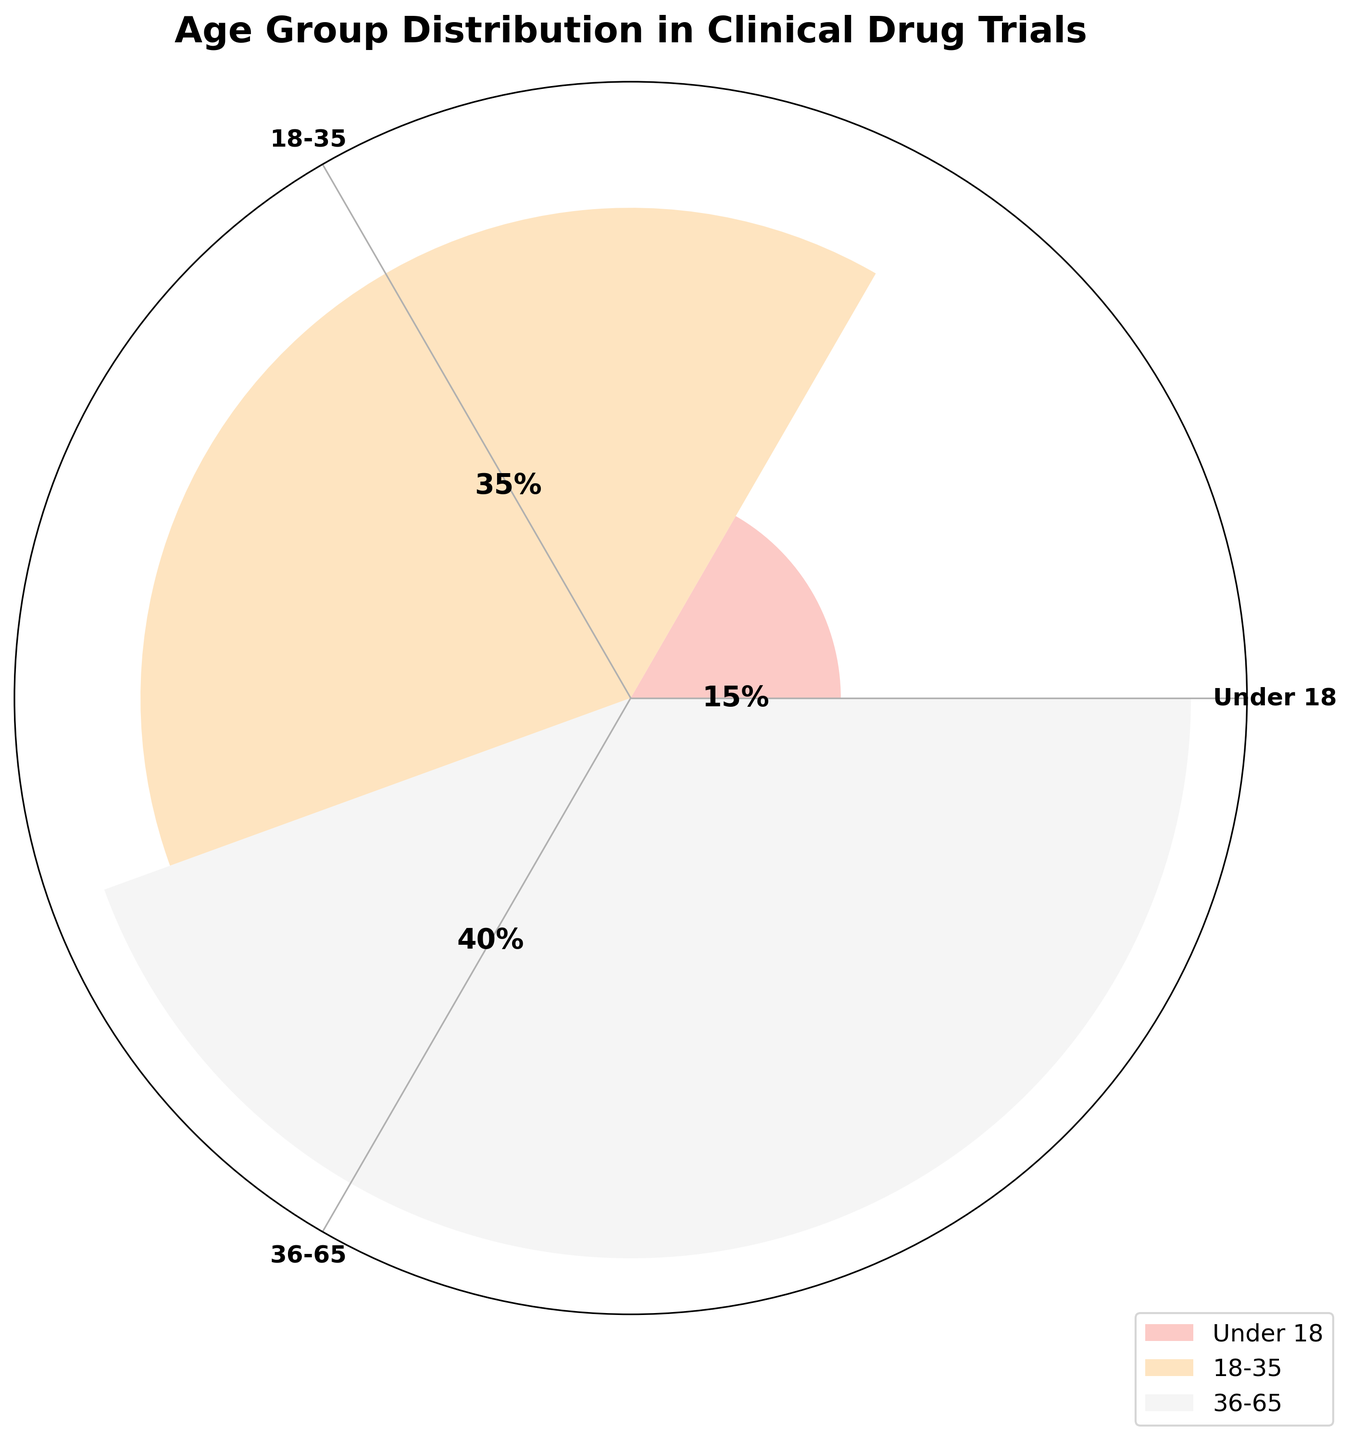what is the title of the figure? The title of the chart is usually written at the top and summarizes the content of the figure.
Answer: Age Group Distribution in Clinical Drug Trials how many age groups are represented in the figure? By looking at different labels or sections of the chart, we can count the total number of individual age groups.
Answer: 3 which age group has the highest percentage? Identify the segment of the rose chart with the largest size or the segment labeled with the highest percentage.
Answer: 36-65 how does the percentage of the 18-35 age group compare to the percentage of the over 65 age group? By referring to the labeled percentages on the chart, compare the values associated with the 18-35 and over 65 age groups.
Answer: Greater what is the total percentage represented by all shown age groups? Sum the percentages of all age groups depicted in the chart: 15% + 35% + 40% = 90%.
Answer: 90% what is the average percentage of the 3 age groups shown? Sum the percentages (15 + 35 + 40) and then divide by the number of age groups (3): (15 + 35 + 40)/3.
Answer: 30% which age group falls in the middle in terms of percentage size? Sort the age groups by percentage and identify which one is in the middle. In this case, the groups are 15%, 35%, and 40%; hence, 35% is the middle value.
Answer: 18-35 how much larger is the percentage of the 36-65 age group compared to the under 18 age group? Subtract the percentage of the under 18 age group from that of the 36-65 age group: 40% - 15%.
Answer: 25% which segment is the smallest in terms of percentage and what color is it? Identify the segment with the smallest percentage and note its color in the rose chart.
Answer: Under 18, Pastel Color 